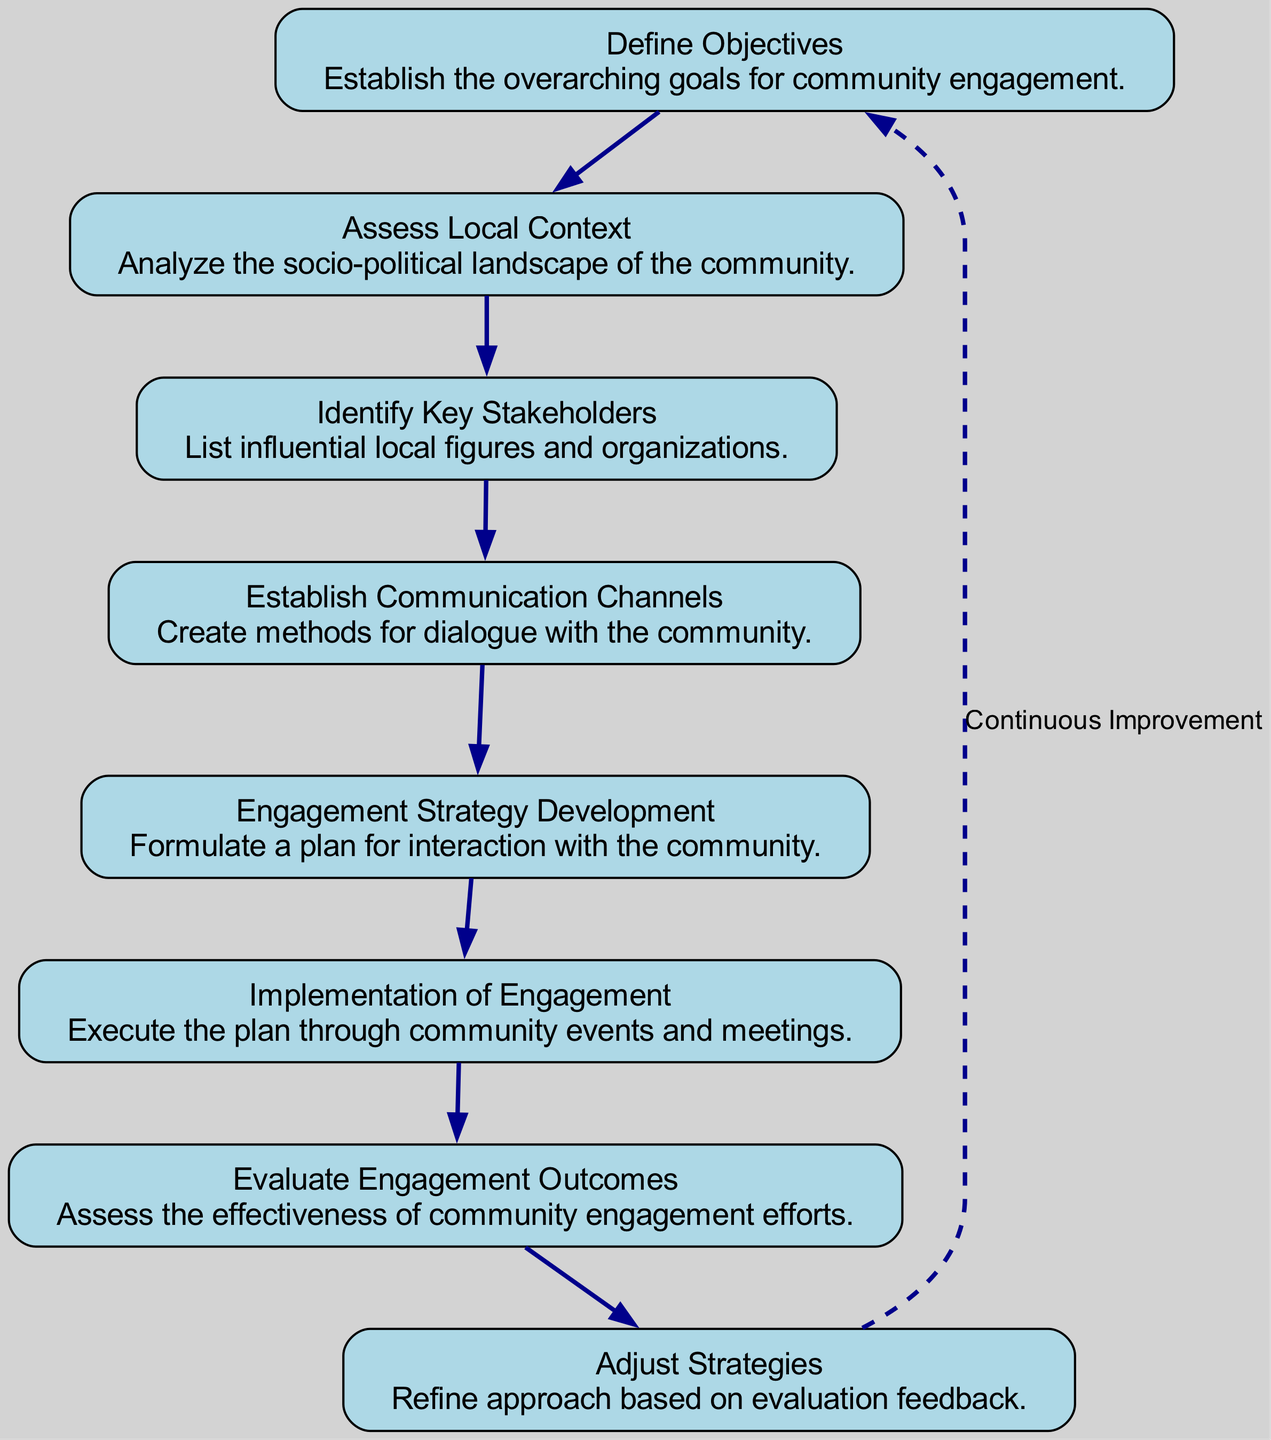What's the first step in the engagement process? The diagram starts with the node labeled "Define Objectives," indicating that this is the first step in the engagement process.
Answer: Define Objectives How many nodes are present in the diagram? By counting the numbered elements in the diagram, there are a total of eight distinct nodes representing different steps in the decision-making process.
Answer: 8 What follows after the "Assess Local Context"? The flow from "Assess Local Context" directly leads to "Identify Key Stakeholders," showing the sequential nature of the steps.
Answer: Identify Key Stakeholders What is the last step before "Evaluate Engagement Outcomes"? The last step before "Evaluate Engagement Outcomes" is "Implementation of Engagement," which precedes the evaluation phase in the flow.
Answer: Implementation of Engagement Which step involves adjusting the strategies? The step labeled "Adjust Strategies" focuses on refining approaches based on the feedback and evaluation from the prior steps in the engagement process.
Answer: Adjust Strategies What is indicated by the dashed edge in the diagram? The dashed edge from the last node back to "Define Objectives" indicates a process of "Continuous Improvement," suggesting that the entire engagement process is iterative.
Answer: Continuous Improvement Which step requires the assessment of effectiveness? The step "Evaluate Engagement Outcomes" specifically addresses the need to assess the effectiveness of the earlier community engagement efforts in the flow chart.
Answer: Evaluate Engagement Outcomes Which two steps are directly connected to "Engagement Strategy Development"? "Establish Communication Channels" precedes "Engagement Strategy Development," showing a direct connection between these two steps in the decision-making process.
Answer: Establish Communication Channels, Engagement Strategy Development 